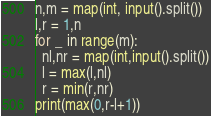Convert code to text. <code><loc_0><loc_0><loc_500><loc_500><_Python_>n,m = map(int, input().split())
l,r = 1,n
for _ in range(m):
  nl,nr = map(int,input().split())
  l = max(l,nl)
  r = min(r,nr)
print(max(0,r-l+1))</code> 